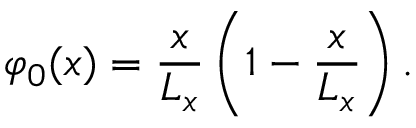<formula> <loc_0><loc_0><loc_500><loc_500>\varphi _ { 0 } ( x ) = \frac { x } { L _ { x } } \left ( 1 - \frac { x } { L _ { x } } \right ) .</formula> 